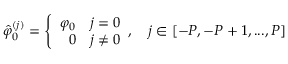Convert formula to latex. <formula><loc_0><loc_0><loc_500><loc_500>\hat { \varphi } _ { 0 } ^ { ( j ) } = \left \{ \begin{array} { r l } { \varphi _ { 0 } } & { j = 0 } \\ { 0 } & { j \neq 0 } \end{array} , \quad j \in [ - P , - P + 1 , \dots , P ]</formula> 